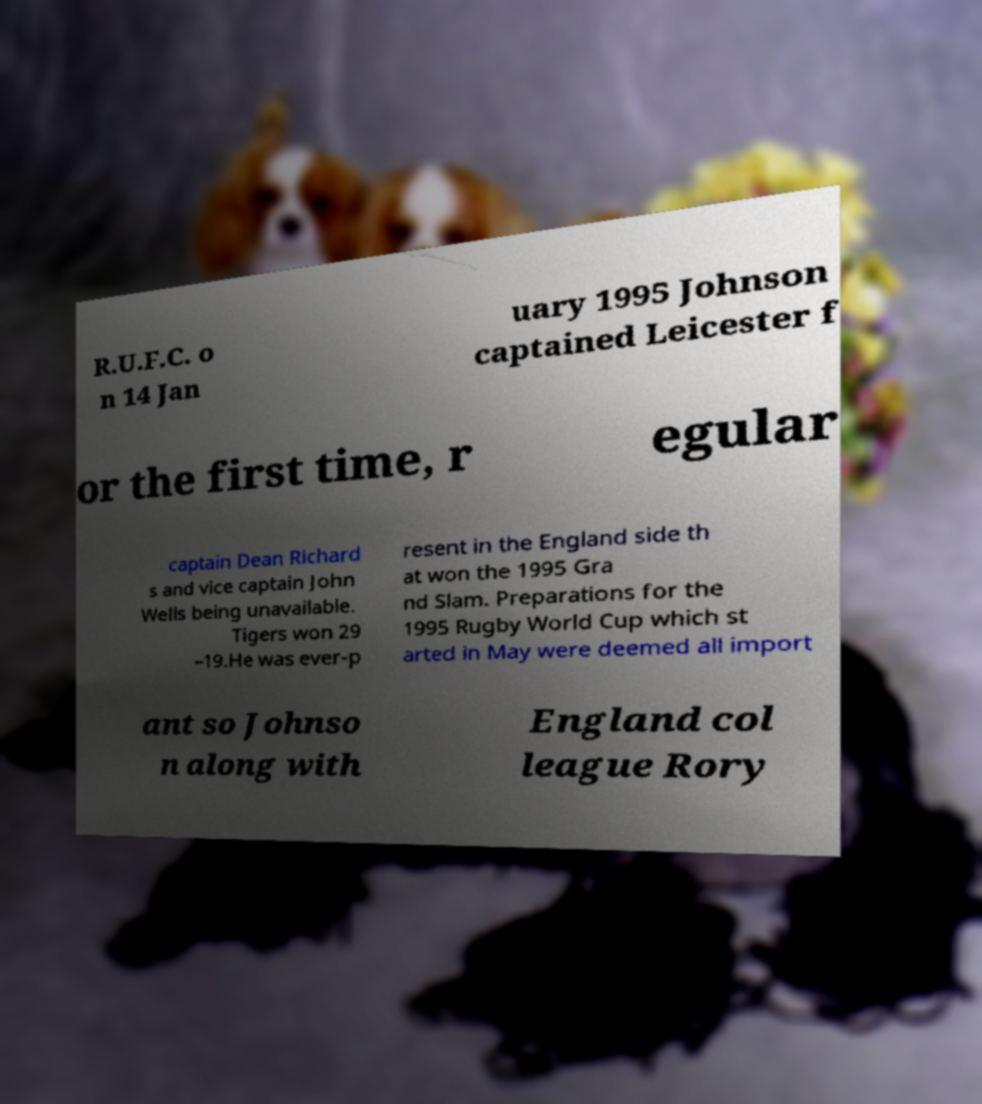Please read and relay the text visible in this image. What does it say? R.U.F.C. o n 14 Jan uary 1995 Johnson captained Leicester f or the first time, r egular captain Dean Richard s and vice captain John Wells being unavailable. Tigers won 29 –19.He was ever-p resent in the England side th at won the 1995 Gra nd Slam. Preparations for the 1995 Rugby World Cup which st arted in May were deemed all import ant so Johnso n along with England col league Rory 